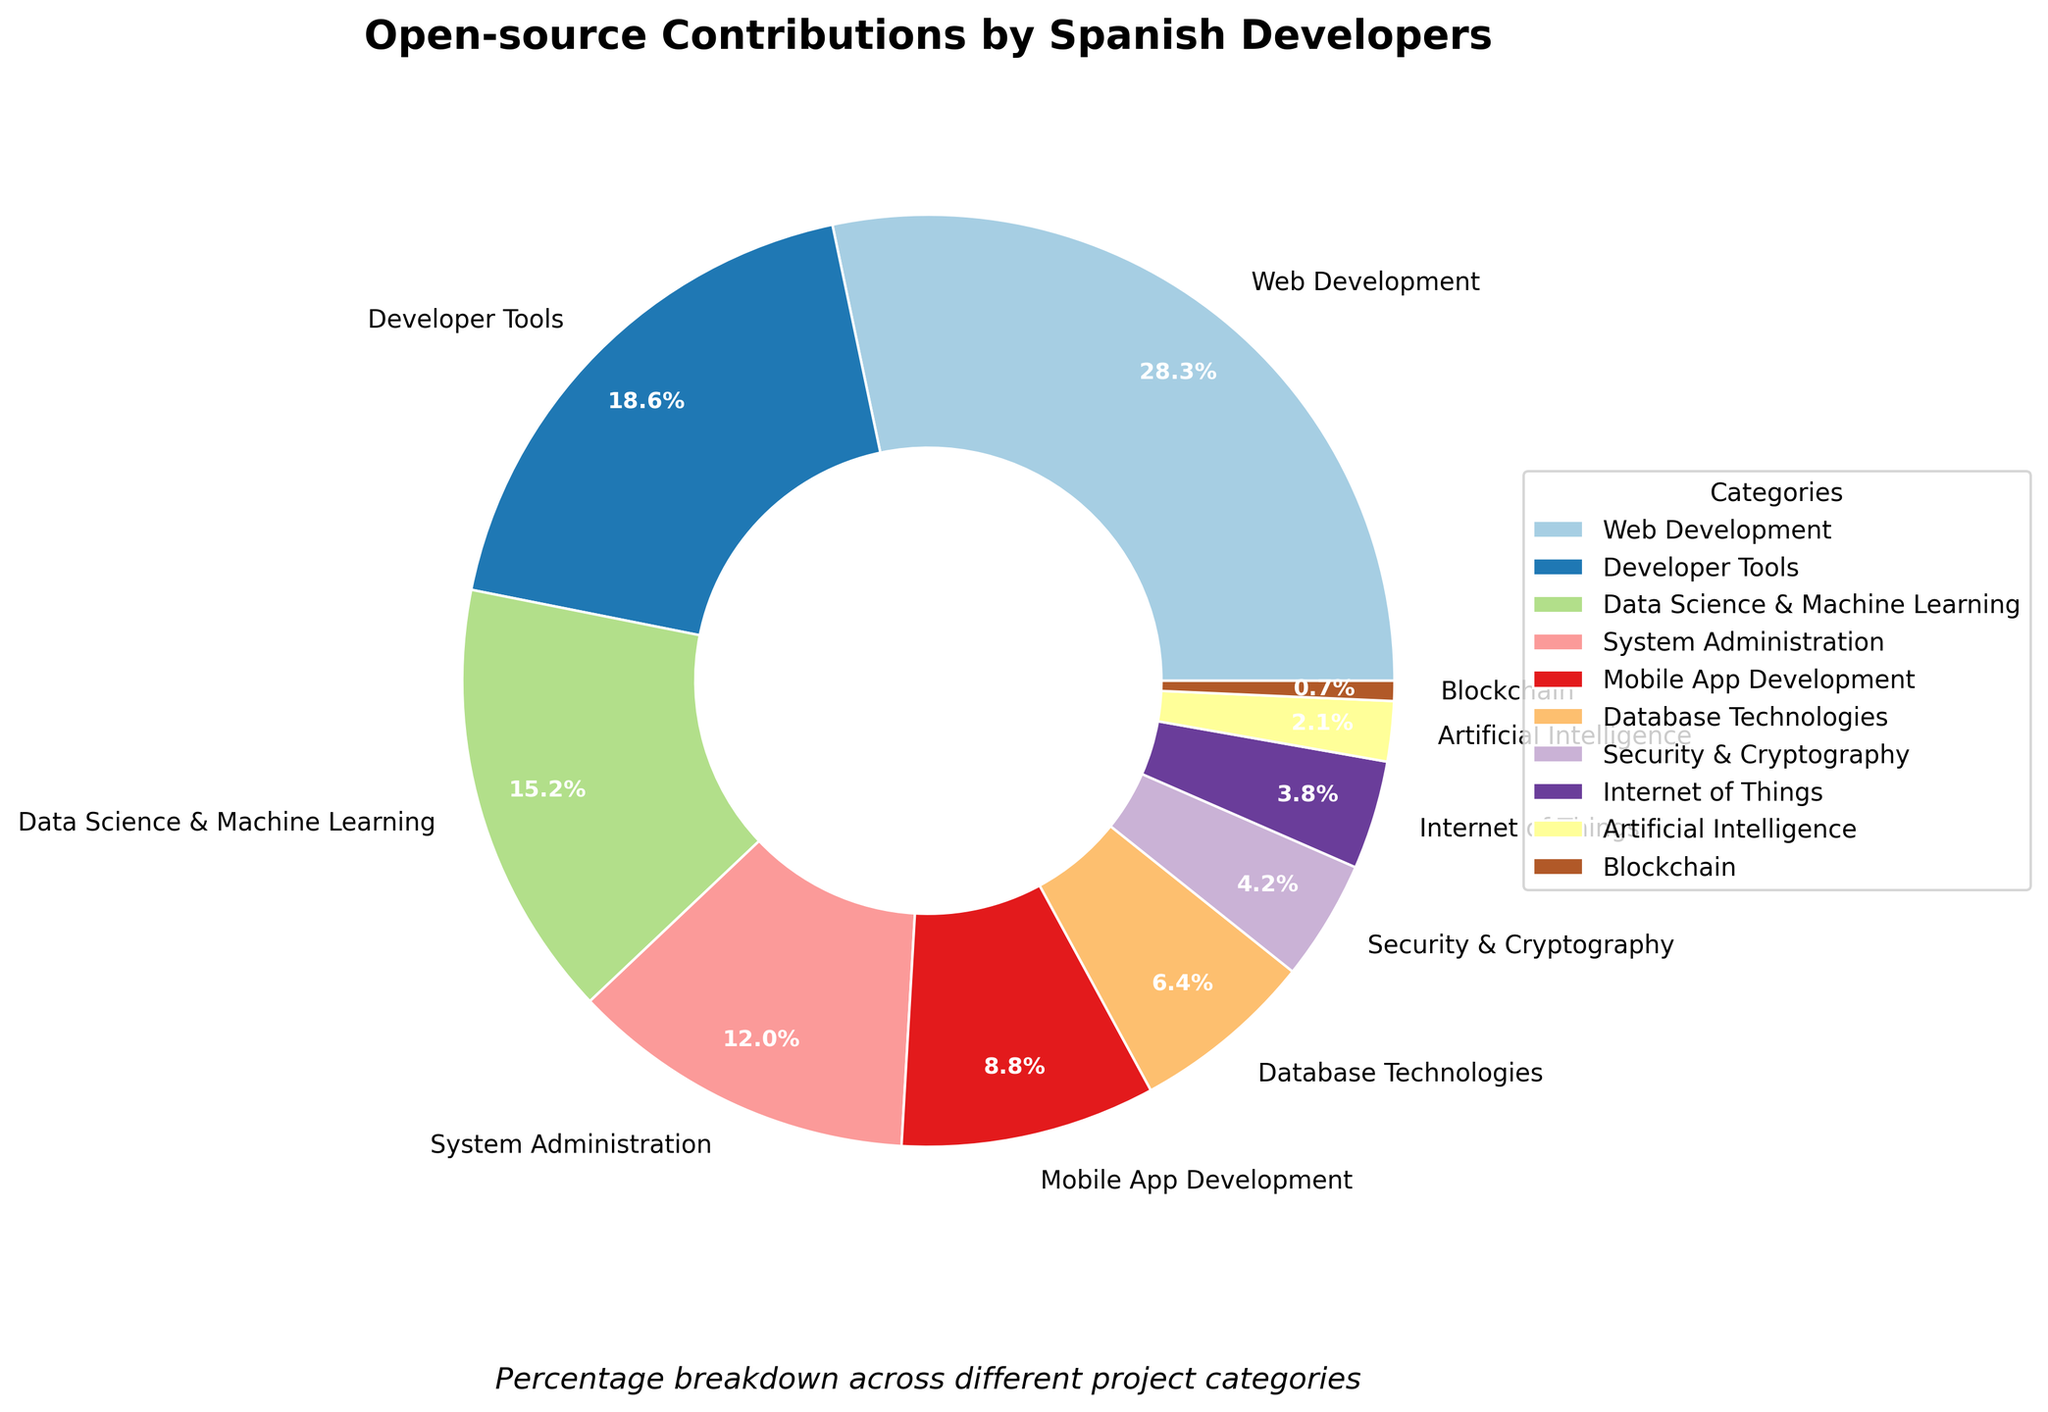Which category has the highest percentage of contributions? By looking at the figure, the category with the largest wedge in the pie chart corresponds to "Web Development".
Answer: Web Development What is the combined percentage of contributions for Developer Tools and Data Science & Machine Learning? Add the percentage values for both categories: 18.7% (Developer Tools) + 15.3% (Data Science & Machine Learning) = 34.0%.
Answer: 34.0% Which categories have a contribution percentage lower than 5%? The categories with contribution percentages lower than 5% are those with the smallest wedges. From the figure, these categories are Security & Cryptography (4.2%), Internet of Things (3.8%), Artificial Intelligence (2.1%), and Blockchain (0.7%).
Answer: Security & Cryptography, Internet of Things, Artificial Intelligence, Blockchain Does the combined contribution of Mobile App Development and Database Technologies exceed that of System Administration? Add the percentages of Mobile App Development (8.9%) and Database Technologies (6.4%) to get 15.3%. Compare this with System Administration's 12.1%. Yes, 15.3% is greater than 12.1%.
Answer: Yes What is the difference in percentage contribution between System Administration and Data Science & Machine Learning? Subtract the percentage of System Administration (12.1%) from Data Science & Machine Learning (15.3%): 15.3% - 12.1% = 3.2%.
Answer: 3.2% How many categories contribute more than 10% each? Identify the wedges in the pie chart that correspond to contributions greater than 10%. These are Web Development (28.5%), Developer Tools (18.7%), and Data Science & Machine Learning (15.3%), and System Administration (12.1%). This gives us a total of 4 categories.
Answer: 4 What percentage of the total contributions is made up by categories with less than 10% each? Sum the percentages of categories with less than 10%: Mobile App Development (8.9%), Database Technologies (6.4%), Security & Cryptography (4.2%), Internet of Things (3.8%), Artificial Intelligence (2.1%), and Blockchain (0.7%). This totals: 8.9% + 6.4% + 4.2% + 3.8% + 2.1% + 0.7% = 26.1%.
Answer: 26.1% Is the percentage of contributions to Artificial Intelligence closer to that of Blockchain or System Administration? Compare the difference: between Artificial Intelligence (2.1%) and Blockchain (0.7%) is (2.1% - 0.7% = 1.4%) while between Artificial Intelligence (2.1%) and System Administration (12.1%) is (12.1% - 2.1% = 10%). Since 1.4% is less than 10%, Artificial Intelligence is closer in percentage to Blockchain.
Answer: Blockchain What is the average percentage contribution of the top 3 categories? Find the total percentage of the top 3 categories and divide by 3. The top 3 categories are Web Development (28.5%), Developer Tools (18.7%), and Data Science & Machine Learning (15.3%). The total is 28.5% + 18.7% + 15.3% = 62.5%. The average is 62.5% / 3 = 20.83%.
Answer: 20.83% 